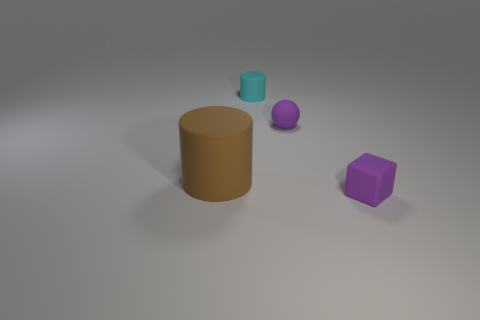Subtract all balls. How many objects are left? 3 Add 1 big green metallic blocks. How many objects exist? 5 Subtract all tiny blue shiny things. Subtract all tiny purple blocks. How many objects are left? 3 Add 1 purple rubber blocks. How many purple rubber blocks are left? 2 Add 4 cylinders. How many cylinders exist? 6 Subtract 0 yellow blocks. How many objects are left? 4 